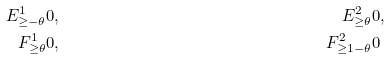Convert formula to latex. <formula><loc_0><loc_0><loc_500><loc_500>E ^ { 1 } _ { \geq - \theta } & 0 , & \quad E ^ { 2 } _ { \geq \theta } & 0 , \\ F ^ { 1 } _ { \geq \theta } & 0 , & F ^ { 2 } _ { \geq 1 - \theta } & 0</formula> 